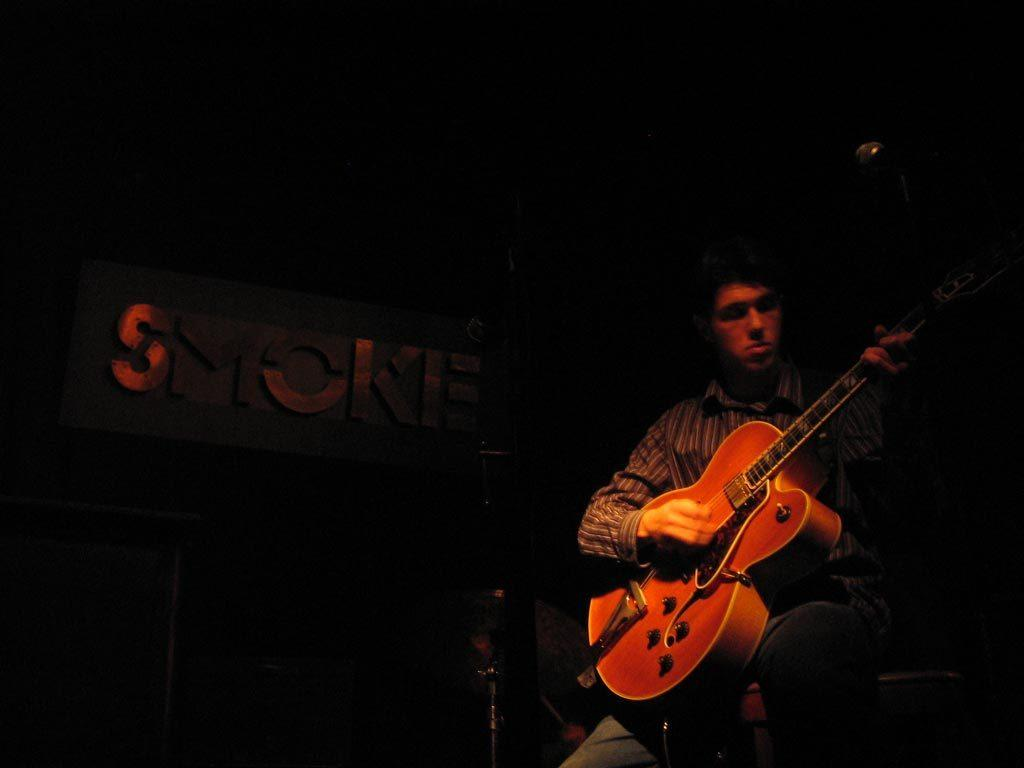What is the man doing in the image? The man is sitting on the right side of the image and playing a guitar. What can be seen on the left side of the image? There is a board on the left side of the image. What type of screw is being used to hold the quill in the wilderness in the image? There is no screw, quill, or wilderness present in the image. 